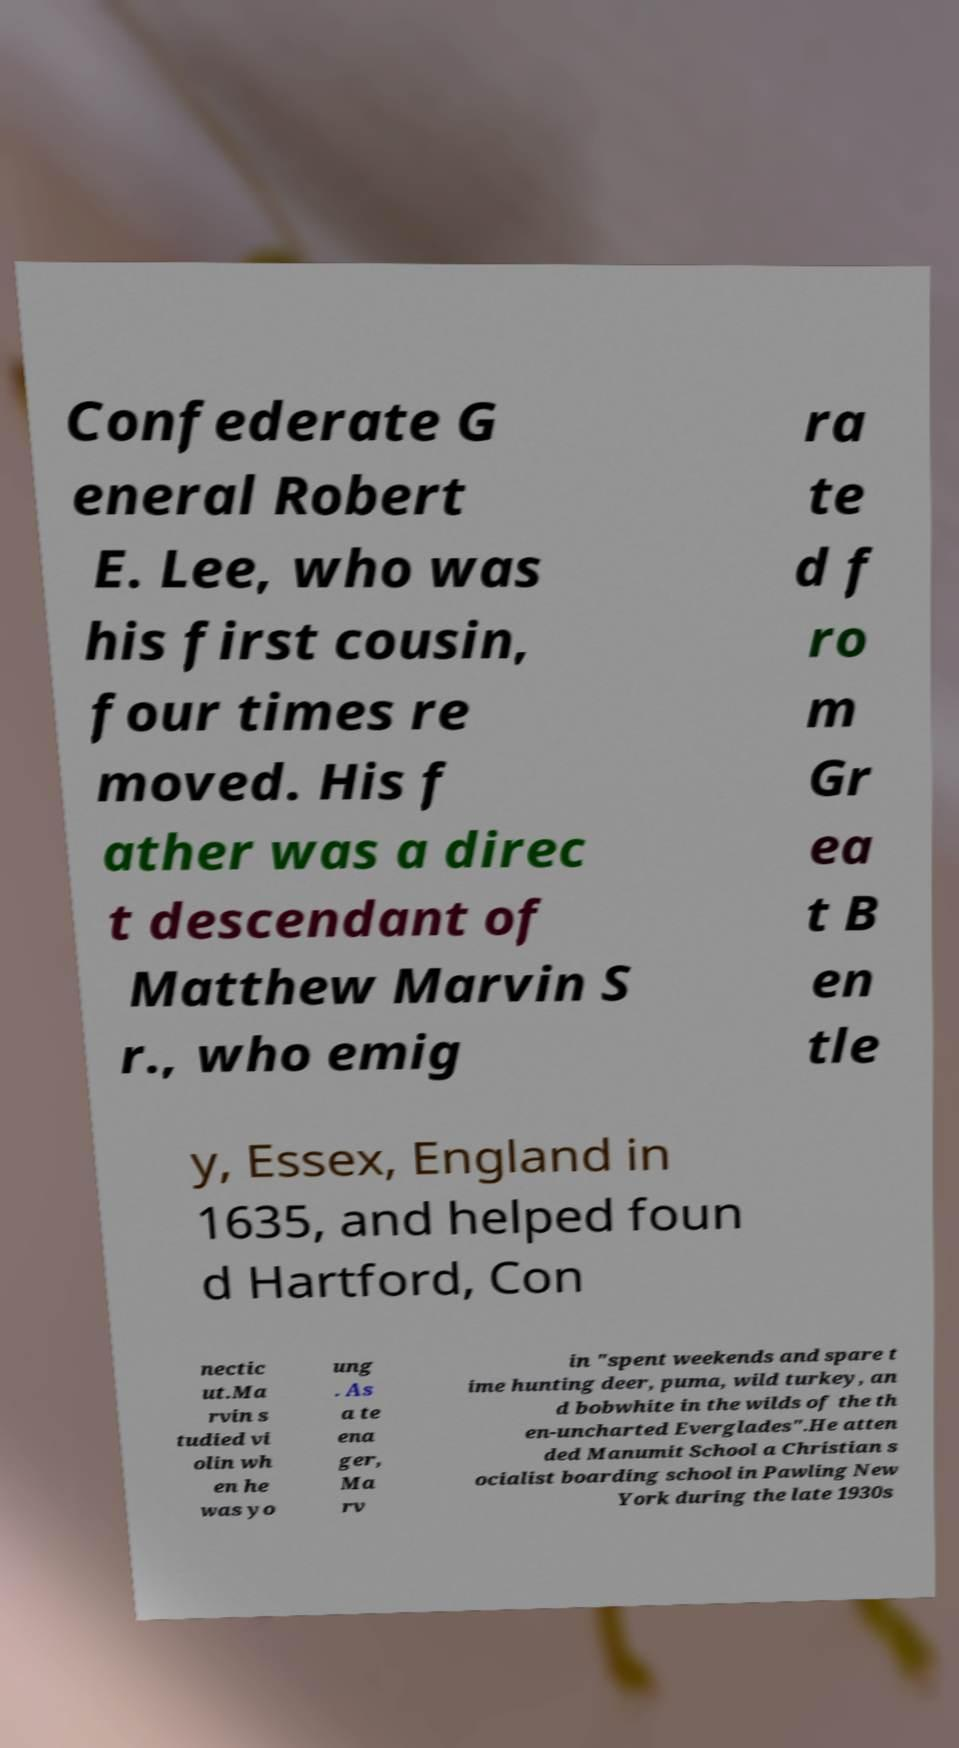What messages or text are displayed in this image? I need them in a readable, typed format. Confederate G eneral Robert E. Lee, who was his first cousin, four times re moved. His f ather was a direc t descendant of Matthew Marvin S r., who emig ra te d f ro m Gr ea t B en tle y, Essex, England in 1635, and helped foun d Hartford, Con nectic ut.Ma rvin s tudied vi olin wh en he was yo ung . As a te ena ger, Ma rv in "spent weekends and spare t ime hunting deer, puma, wild turkey, an d bobwhite in the wilds of the th en-uncharted Everglades".He atten ded Manumit School a Christian s ocialist boarding school in Pawling New York during the late 1930s 